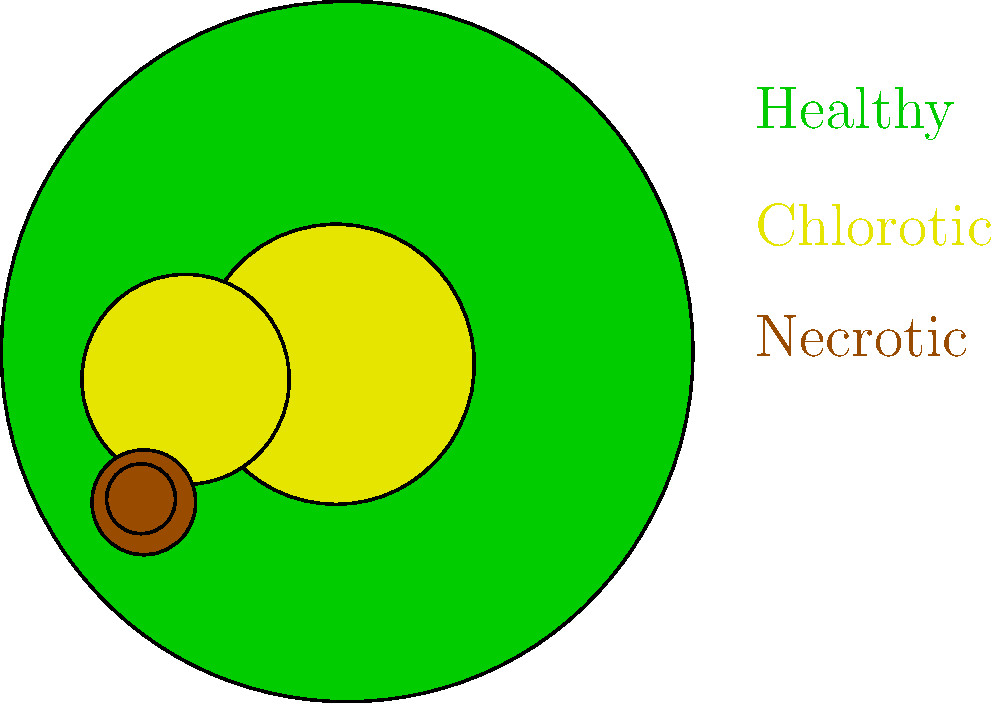Based on the color-coded leaf diagram, which of the following disease symptoms are present, and what potential pathogen group might be responsible for these symptoms? To answer this question, we need to analyze the color-coded leaf diagram and interpret the symptoms:

1. Green areas: These represent healthy leaf tissue.

2. Yellow areas: These indicate chlorosis, which is a yellowing of plant tissue due to a lack of chlorophyll. Chlorosis is often an early symptom of many plant diseases.

3. Brown areas: These represent necrosis, which is dead plant tissue. Necrosis often appears as brown or black spots on leaves.

Given these observations, we can conclude that the leaf shows both chlorotic and necrotic symptoms.

Potential pathogen groups that could cause these symptoms include:

1. Fungi: Many fungal pathogens can cause both chlorosis and necrosis. Examples include Cercospora leaf spot or early blight.

2. Bacteria: Some bacterial pathogens can cause similar symptoms, such as bacterial leaf spot.

3. Viruses: Certain plant viruses can induce chlorosis, and in advanced stages, necrosis.

4. Oomycetes: Pathogens like Phytophthora can cause both chlorosis and necrosis.

However, without additional information about the specific plant species and environmental conditions, it's not possible to pinpoint a single pathogen group. The combination of chlorosis and necrosis is a common pattern in many plant diseases caused by various pathogen types.
Answer: Chlorosis and necrosis; potentially caused by fungi, bacteria, viruses, or oomycetes. 